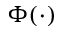<formula> <loc_0><loc_0><loc_500><loc_500>\Phi ( \cdot )</formula> 